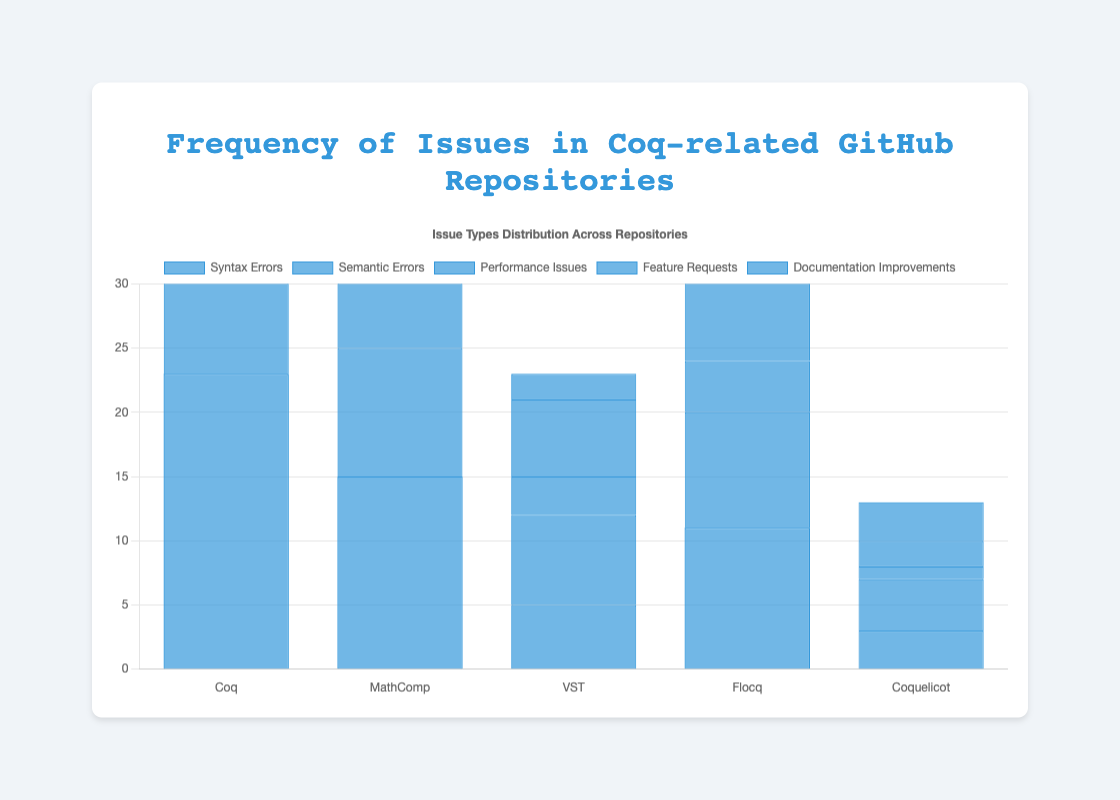Which repository has the highest number of feature requests? By looking at the height of the bars representing feature requests, we can see which one is the tallest. The tallest bar for feature requests belongs to the "Coq" repository.
Answer: Coq What is the total number of reported syntax errors across all repositories? Add the frequencies of syntax errors reported in each repository: Coq (23) + MathComp (15) + VST (5) + Flocq (11) + Coquelicot (3) = 57.
Answer: 57 How does the frequency of performance issues in MathComp compare to Coquelicot? Compare the height of the bars for performance issues in both repositories. MathComp's frequency is 8 while Coquelicot's is 1, so MathComp has more performance issues reported than Coquelicot.
Answer: MathComp has more Which repository reported the least number of documentation improvements? Look for the shortest bar in the "Documentation Improvements" category. The shortest bar belongs to "VST" with a frequency of 2.
Answer: VST What is the average number of semantic errors reported across all repositories? Add up the frequencies of semantic errors in all repositories and then divide by the number of repositories: (17 + 10 + 7 + 9 + 4) / 5 = 47 / 5 = 9.4.
Answer: 9.4 Which issue type in the Coq repository has the highest frequency? By examining the heights of the bars for the Coq repository, we see that Feature Requests has the highest bar at 28.
Answer: Feature Requests How many more feature requests than syntax errors were reported in the Flocq repository? Subtract the frequency of syntax errors from the frequency of feature requests in Flocq: 7 - 11 = -4 (indicating there are actually more syntax errors than feature requests).
Answer: 4 fewer What is the combined frequency of documentation improvements across all repositories? Sum the frequencies of documentation improvements in all repositories: 20 (Coq) + 9 (MathComp) + 2 (VST) + 5 (Flocq) + 3 (Coquelicot) = 39.
Answer: 39 If you add the number of syntax errors and performance issues in the Coquelicot repository, how does it compare to the number of semantic errors in the same repository? Add the frequencies of syntax errors and performance issues in Coquelicot: 3 + 1 = 4, which is equal to the number of semantic errors in Coquelicot (4).
Answer: They are equal What is the total number of issues reported in the MathComp repository? Sum all the types of issues reported in MathComp: 15 (Syntax Errors) + 10 (Semantic Errors) + 8 (Performance Issues) + 13 (Feature Requests) + 9 (Documentation Improvements) = 55.
Answer: 55 